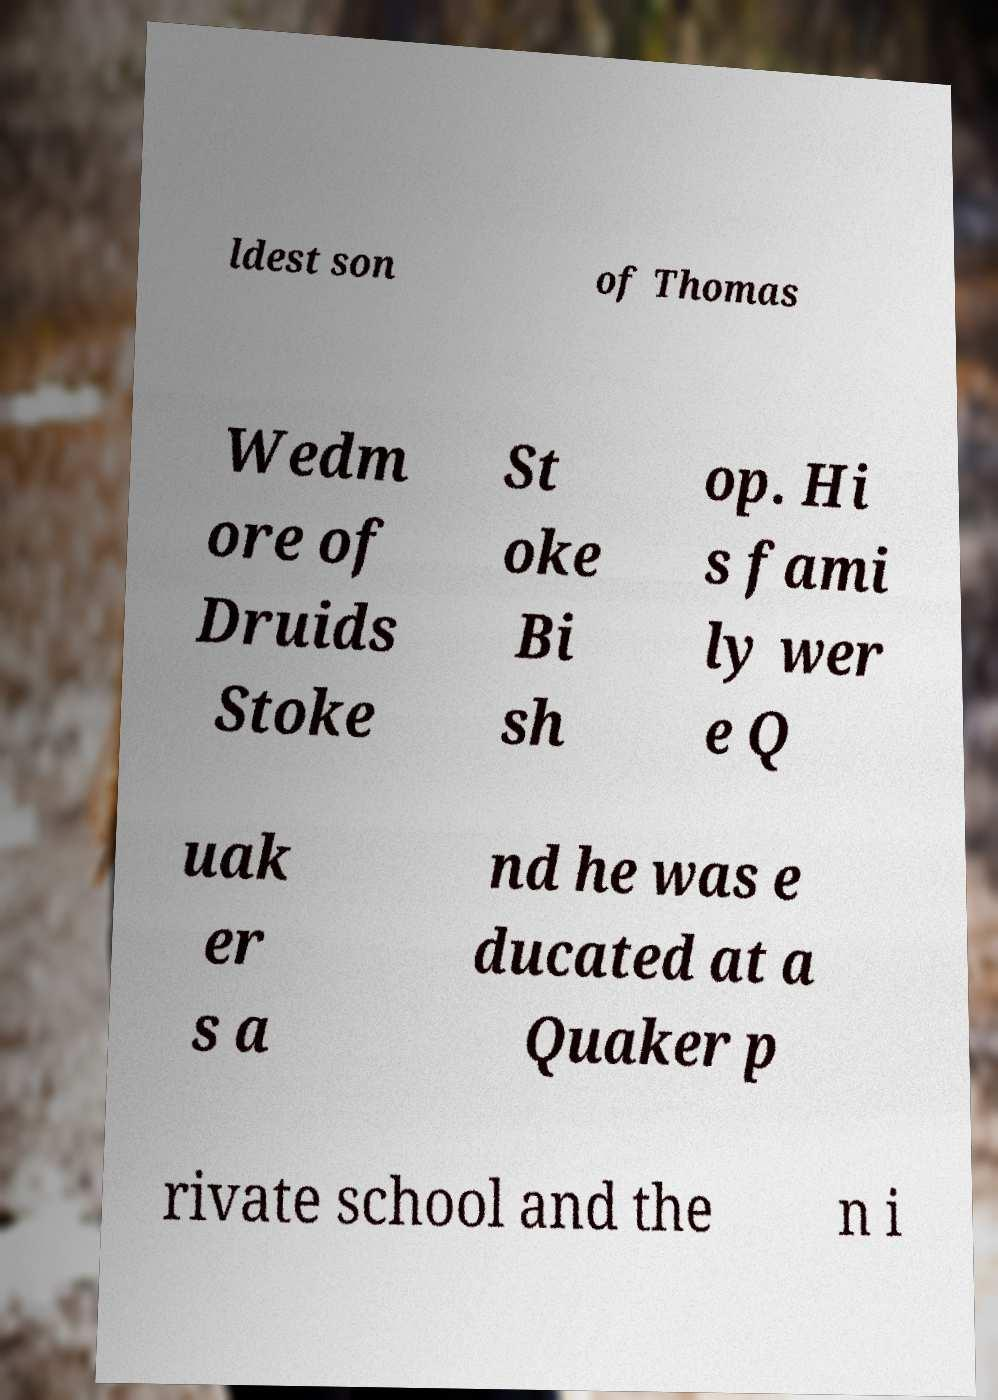For documentation purposes, I need the text within this image transcribed. Could you provide that? ldest son of Thomas Wedm ore of Druids Stoke St oke Bi sh op. Hi s fami ly wer e Q uak er s a nd he was e ducated at a Quaker p rivate school and the n i 